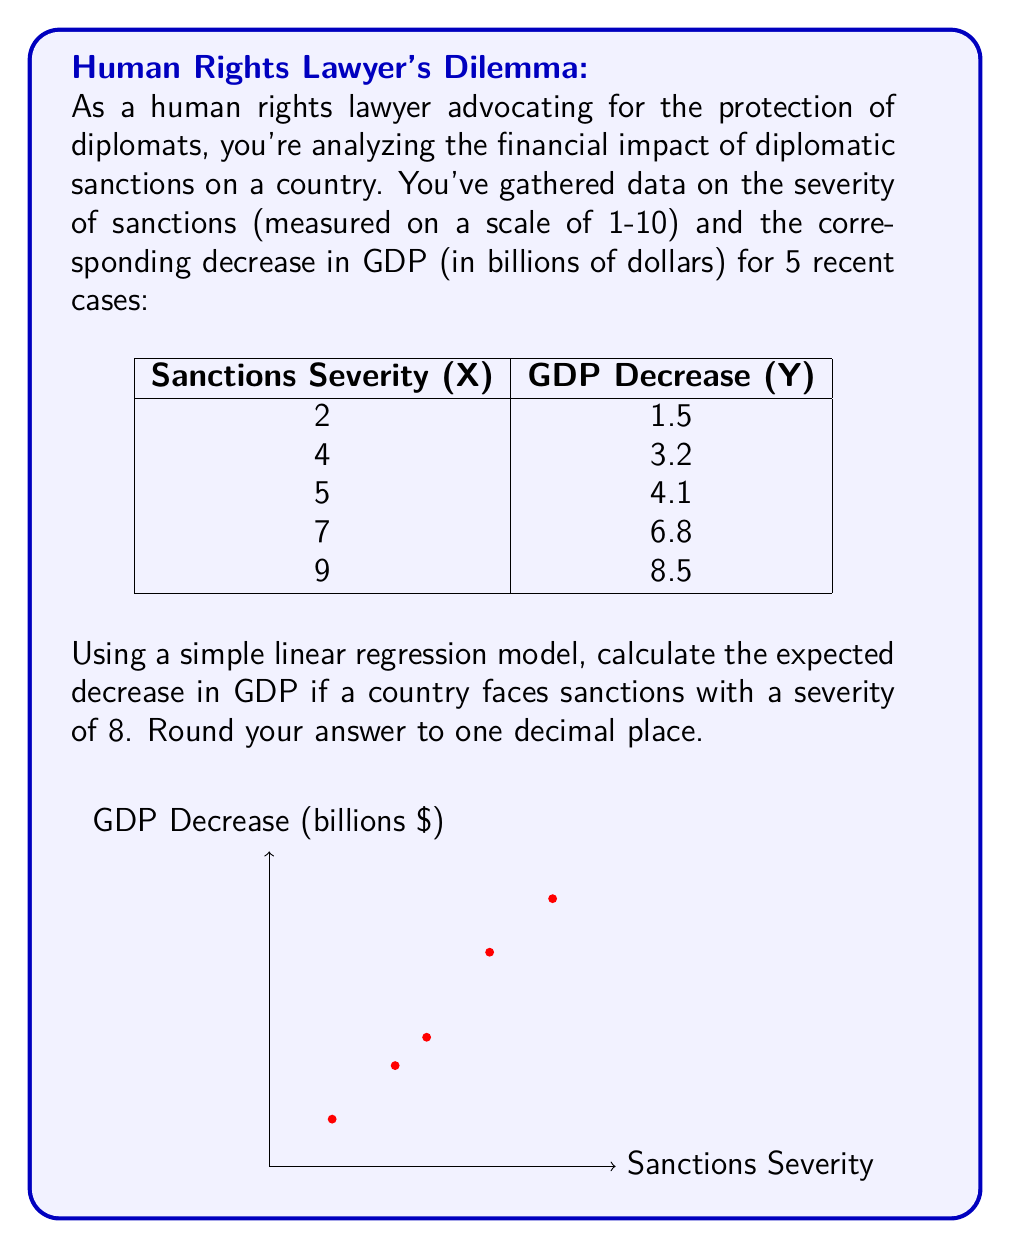Can you solve this math problem? To solve this problem, we'll use the simple linear regression model:

$$ Y = \beta_0 + \beta_1X + \epsilon $$

Where $Y$ is the GDP decrease, $X$ is the sanctions severity, $\beta_0$ is the y-intercept, $\beta_1$ is the slope, and $\epsilon$ is the error term.

Step 1: Calculate the means of X and Y
$\bar{X} = \frac{2+4+5+7+9}{5} = 5.4$
$\bar{Y} = \frac{1.5+3.2+4.1+6.8+8.5}{5} = 4.82$

Step 2: Calculate $\beta_1$ (slope)
$$ \beta_1 = \frac{\sum(X_i - \bar{X})(Y_i - \bar{Y})}{\sum(X_i - \bar{X})^2} $$

$\sum(X_i - \bar{X})(Y_i - \bar{Y}) = 50.18$
$\sum(X_i - \bar{X})^2 = 34.8$

$\beta_1 = \frac{50.18}{34.8} = 1.442$

Step 3: Calculate $\beta_0$ (y-intercept)
$$ \beta_0 = \bar{Y} - \beta_1\bar{X} $$
$\beta_0 = 4.82 - (1.442 * 5.4) = -2.9468$

Step 4: Our regression equation is:
$$ Y = -2.9468 + 1.442X $$

Step 5: Calculate the expected GDP decrease for X = 8
$Y = -2.9468 + 1.442(8) = 8.5896$

Rounding to one decimal place: 8.6
Answer: $8.6 billion 